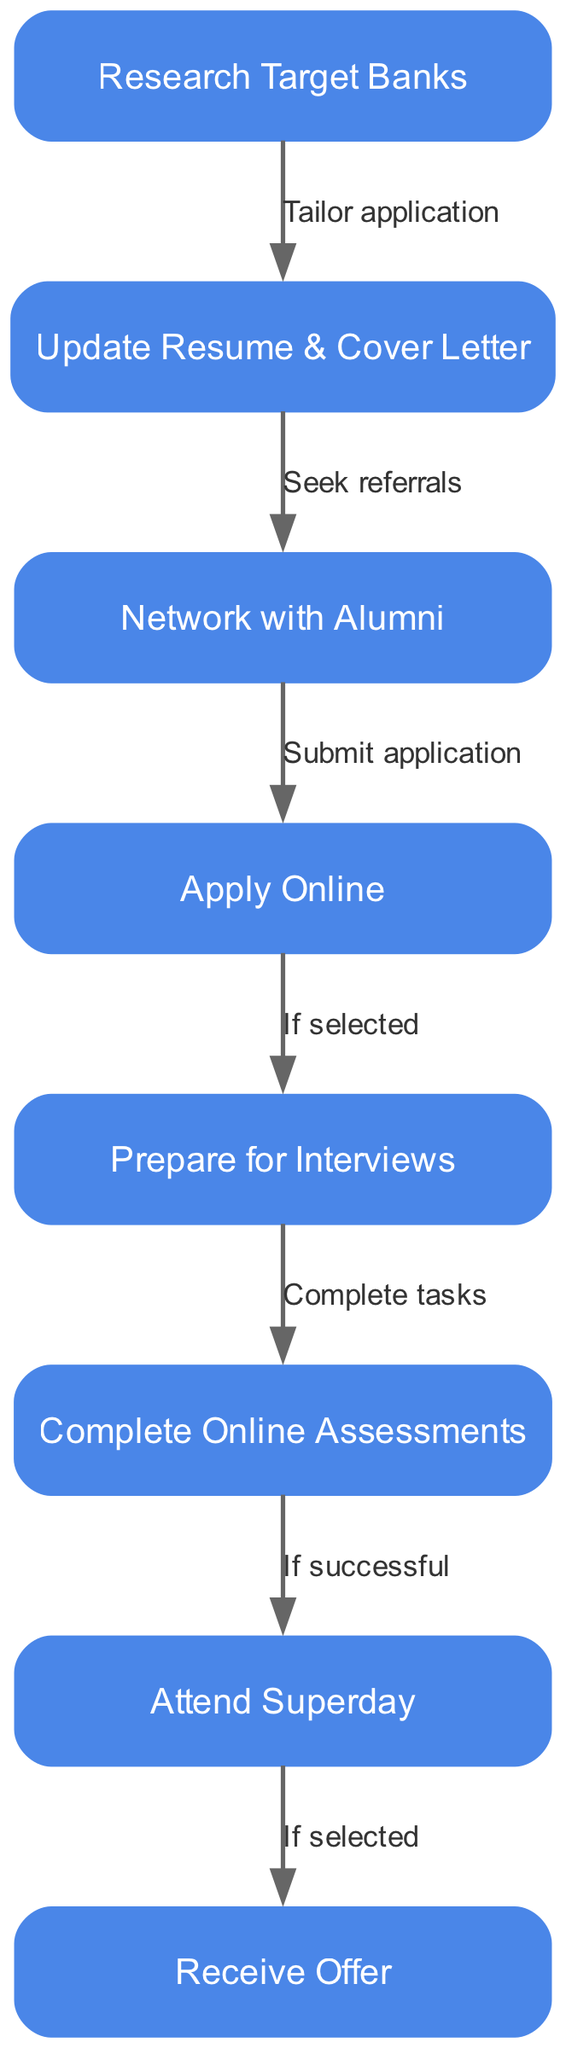What is the first step in the application process? The first node in the diagram is "Research Target Banks," indicating this is the initial step that candidates should take in their application process.
Answer: Research Target Banks How many nodes are present in the application process? By counting each distinct step represented as a node, we identify eight unique nodes in the diagram.
Answer: 8 Which node follows "Update Resume & Cover Letter"? The flow from "Update Resume & Cover Letter" leads directly to "Network with Alumni," making it the next step in the process.
Answer: Network with Alumni What action is taken after submitting an application? Once an application is submitted by following the "Submit application" edge, candidates must prepare for interviews if they are selected.
Answer: Prepare for Interviews What are the possible outcomes after attending Superday? The process indicates that after the "Attend Superday" node, candidates may receive an Offer if they are selected, highlighting a clear end-goal in the application process.
Answer: Receive Offer If selected for an interview, what should a candidate complete beforehand? The diagram specifies that if selected, candidates should "Complete tasks," which refers to online assessments before attending interviews.
Answer: Complete tasks What connects "Network with Alumni" to "Apply Online"? The relationship between these two nodes is expressed by the text "Submit application," indicating that networking leads to applying for opportunities.
Answer: Submit application Which step appears directly before "Attend Superday"? The step "Complete Online Assessments" directly precedes "Attend Superday," suggesting candidates must finish assessments before moving to this stage.
Answer: Complete Online Assessments What is the last node in the application process? The final step or outcome in the diagram is "Receive Offer," representing the conclusion of the internship application journey.
Answer: Receive Offer 